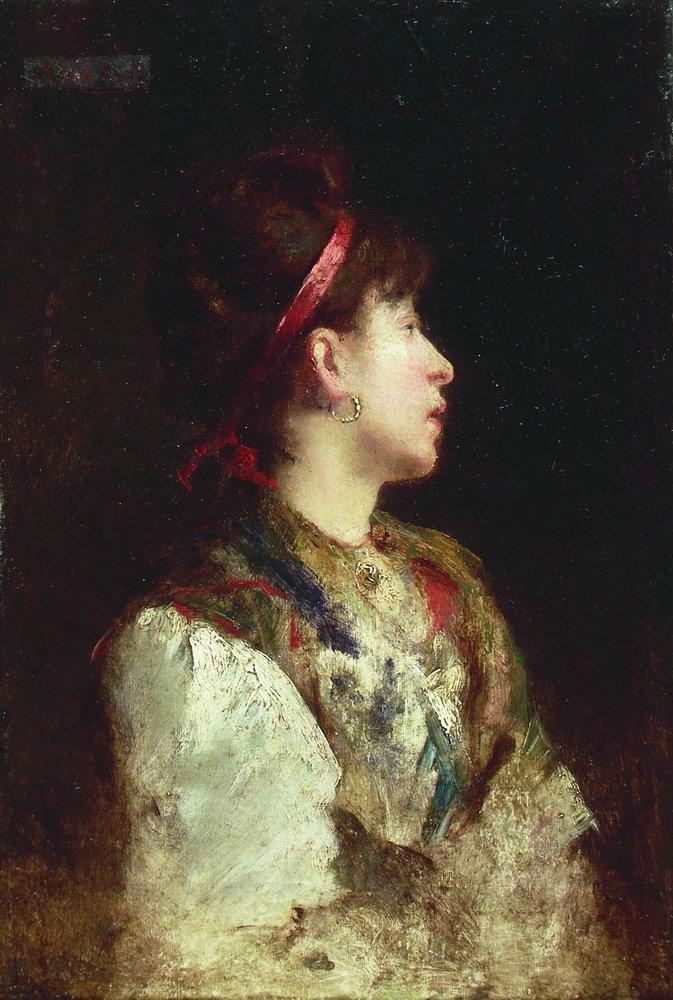What emotions do you think the woman in the portrait is feeling? The woman's expression and the overall composition of the portrait suggest a contemplative and introspective mood. Her profile view, softened by the play of light and shadow, conveys a sense of quiet pensiveness. The use of dark background and the subtle details in her attire hint at a depth of thought or perhaps a moment of personal reflection. 